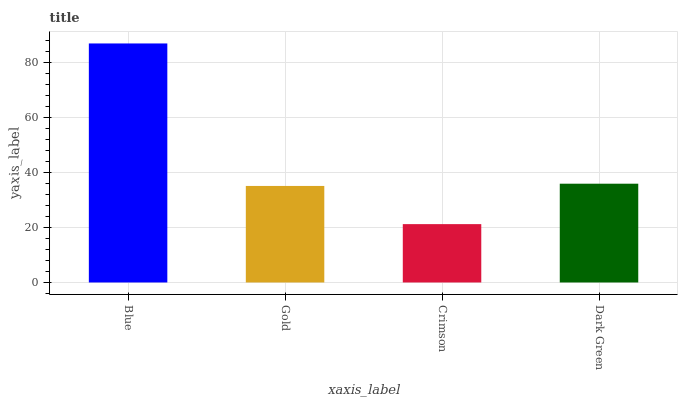Is Crimson the minimum?
Answer yes or no. Yes. Is Blue the maximum?
Answer yes or no. Yes. Is Gold the minimum?
Answer yes or no. No. Is Gold the maximum?
Answer yes or no. No. Is Blue greater than Gold?
Answer yes or no. Yes. Is Gold less than Blue?
Answer yes or no. Yes. Is Gold greater than Blue?
Answer yes or no. No. Is Blue less than Gold?
Answer yes or no. No. Is Dark Green the high median?
Answer yes or no. Yes. Is Gold the low median?
Answer yes or no. Yes. Is Gold the high median?
Answer yes or no. No. Is Blue the low median?
Answer yes or no. No. 